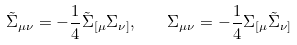Convert formula to latex. <formula><loc_0><loc_0><loc_500><loc_500>\tilde { \Sigma } _ { \mu \nu } = - \frac { 1 } { 4 } \tilde { \Sigma } _ { [ \mu } \Sigma _ { \nu ] } , \quad \Sigma _ { \mu \nu } = - \frac { 1 } { 4 } \Sigma _ { [ \mu } \tilde { \Sigma } _ { \nu ] }</formula> 